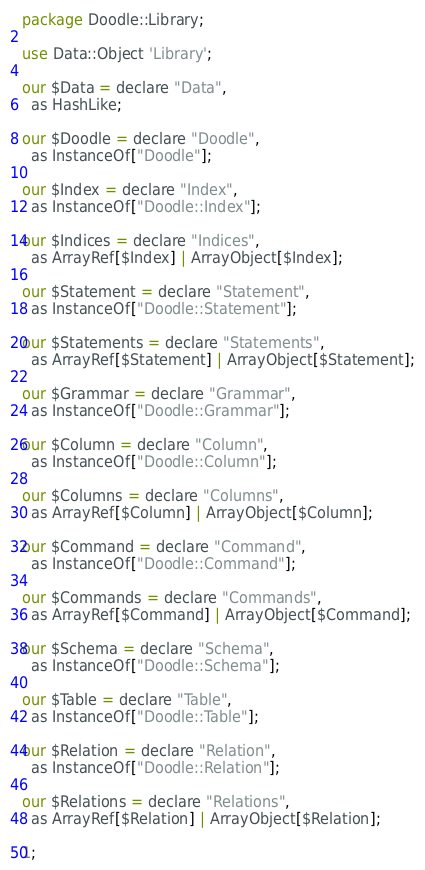<code> <loc_0><loc_0><loc_500><loc_500><_Perl_>package Doodle::Library;

use Data::Object 'Library';

our $Data = declare "Data",
  as HashLike;

our $Doodle = declare "Doodle",
  as InstanceOf["Doodle"];

our $Index = declare "Index",
  as InstanceOf["Doodle::Index"];

our $Indices = declare "Indices",
  as ArrayRef[$Index] | ArrayObject[$Index];

our $Statement = declare "Statement",
  as InstanceOf["Doodle::Statement"];

our $Statements = declare "Statements",
  as ArrayRef[$Statement] | ArrayObject[$Statement];

our $Grammar = declare "Grammar",
  as InstanceOf["Doodle::Grammar"];

our $Column = declare "Column",
  as InstanceOf["Doodle::Column"];

our $Columns = declare "Columns",
  as ArrayRef[$Column] | ArrayObject[$Column];

our $Command = declare "Command",
  as InstanceOf["Doodle::Command"];

our $Commands = declare "Commands",
  as ArrayRef[$Command] | ArrayObject[$Command];

our $Schema = declare "Schema",
  as InstanceOf["Doodle::Schema"];

our $Table = declare "Table",
  as InstanceOf["Doodle::Table"];

our $Relation = declare "Relation",
  as InstanceOf["Doodle::Relation"];

our $Relations = declare "Relations",
  as ArrayRef[$Relation] | ArrayObject[$Relation];

1;
</code> 